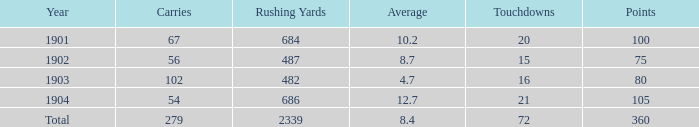What is the most number of touchdowns that have fewer than 105 points, averages over 4.7, and fewer than 487 rushing yards? None. 